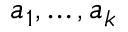Convert formula to latex. <formula><loc_0><loc_0><loc_500><loc_500>a _ { 1 } , \dots , a _ { k }</formula> 